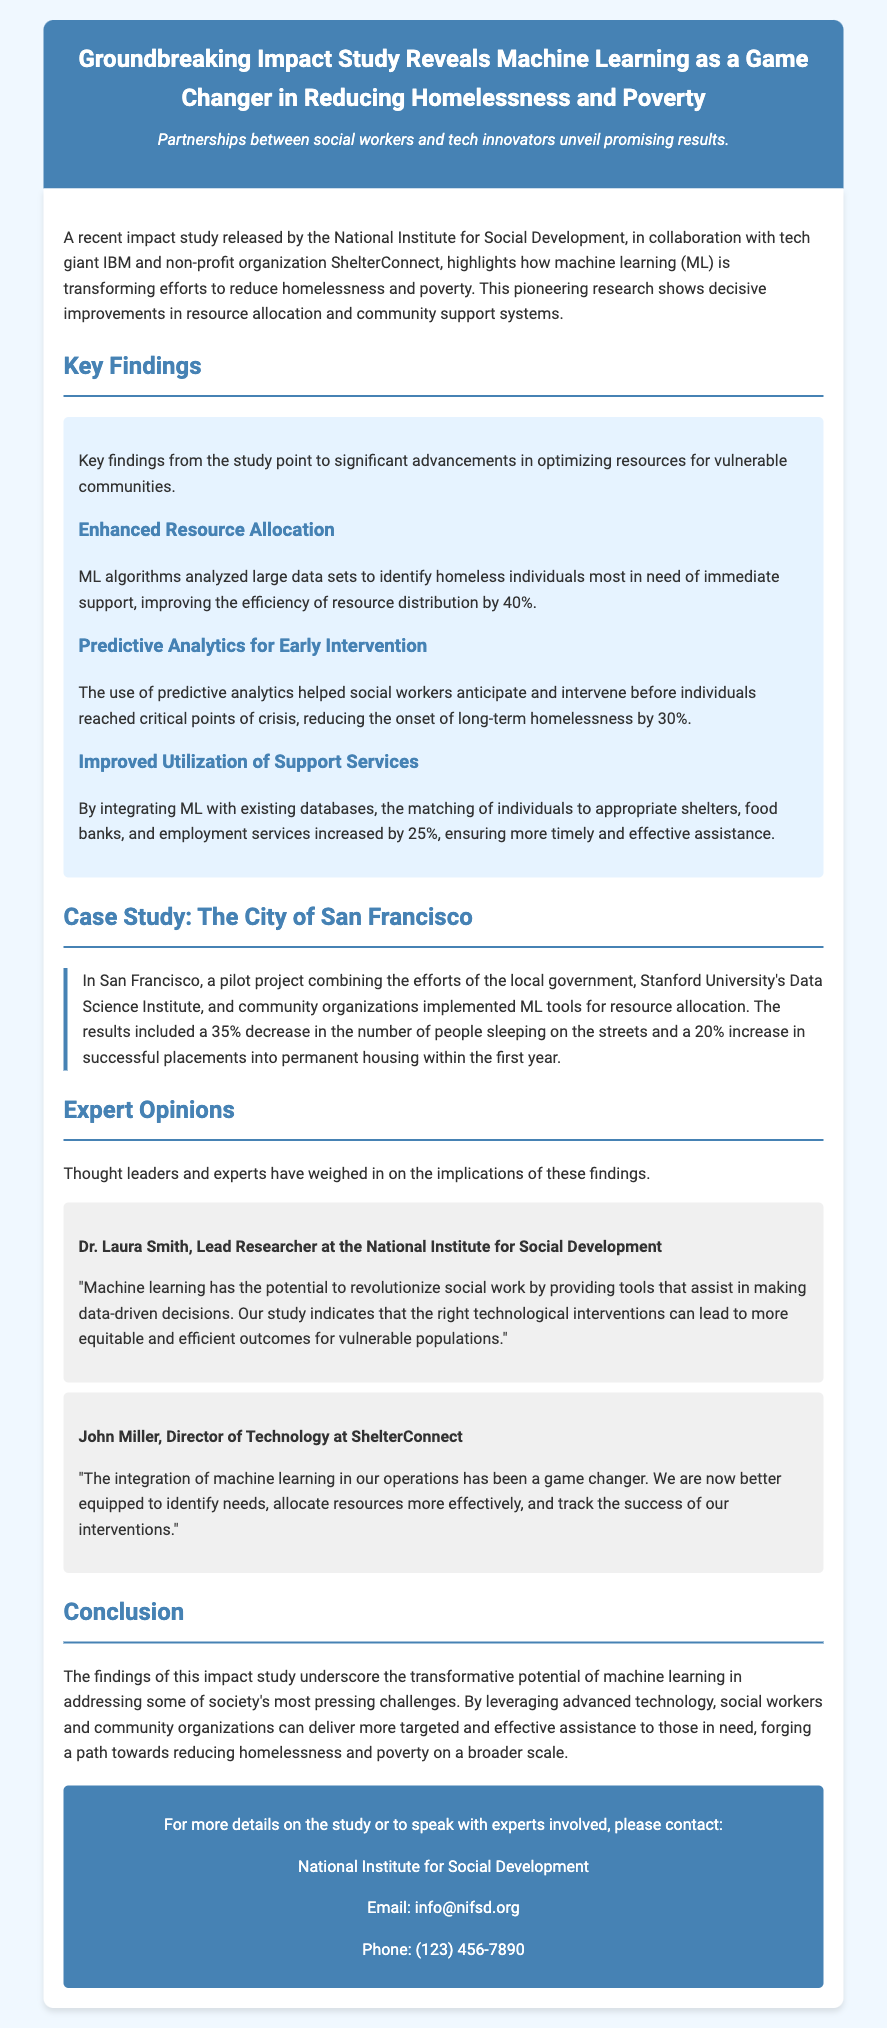What organization released the impact study? The document states that the National Institute for Social Development released the study.
Answer: National Institute for Social Development What percentage improvement was noted in resource distribution efficiency? According to the key findings, resource distribution efficiency improved by 40%.
Answer: 40% How much did long-term homelessness decrease due to predictive analytics? The study indicates that long-term homelessness decreased by 30% due to early interventions using predictive analytics.
Answer: 30% What city was used as a case study for implementing ML tools? The document mentions San Francisco as the city where ML tools were implemented for resource allocation.
Answer: San Francisco Who is the Lead Researcher at the National Institute for Social Development? The document identifies Dr. Laura Smith as the Lead Researcher at the National Institute for Social Development.
Answer: Dr. Laura Smith What was the percentage decrease in people sleeping on the streets in San Francisco? The pilot project in San Francisco resulted in a 35% decrease in the number of people sleeping on the streets.
Answer: 35% Which organization partnered with IBM for the study? The document mentions the non-profit organization ShelterConnect as a partner with IBM for the study.
Answer: ShelterConnect What year did the pilot project in San Francisco start? The document does not specify the year when the pilot project was initiated.
Answer: Not specified How much did successful placements into permanent housing increase by? The results included a 20% increase in successful placements into permanent housing.
Answer: 20% 